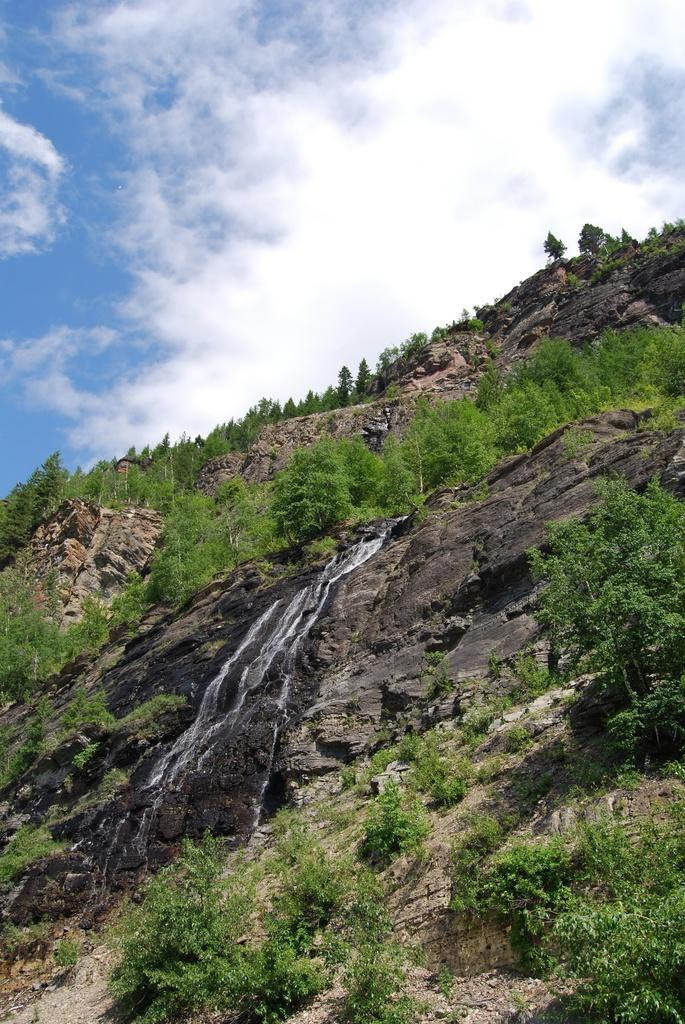What type of vegetation can be seen in the image? There are trees and plants in the image. What type of terrain is visible in the image? There is sand and rocks in the image. What is visible at the top of the image? The sky is visible at the top of the image. How many bees can be seen crawling on the sun in the image? There are no bees or sun present in the image. Can you describe the snail's shell in the image? There is no snail present in the image. 